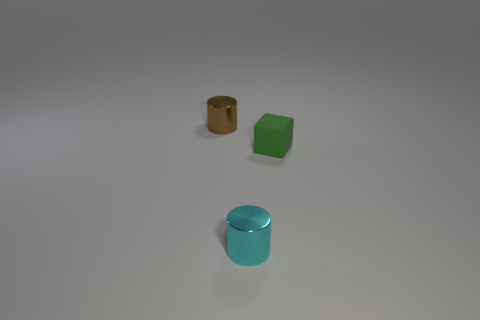Subtract all gray cubes. Subtract all blue cylinders. How many cubes are left? 1 Add 3 large cyan rubber cylinders. How many objects exist? 6 Subtract all cubes. How many objects are left? 2 Add 2 cyan things. How many cyan things are left? 3 Add 2 cyan things. How many cyan things exist? 3 Subtract 0 blue blocks. How many objects are left? 3 Subtract all brown shiny cylinders. Subtract all metallic cylinders. How many objects are left? 0 